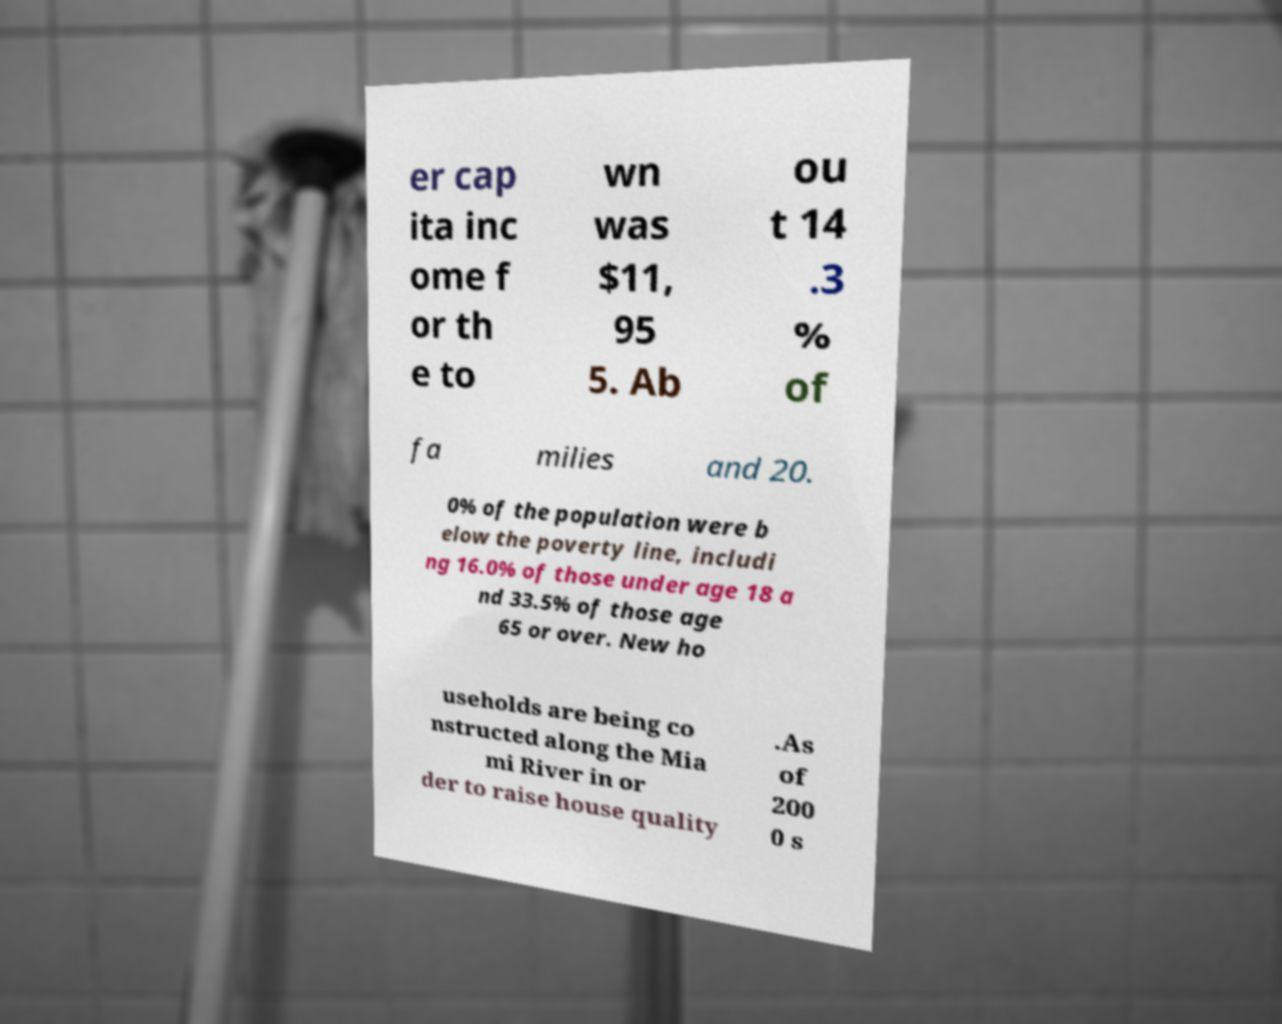Could you extract and type out the text from this image? er cap ita inc ome f or th e to wn was $11, 95 5. Ab ou t 14 .3 % of fa milies and 20. 0% of the population were b elow the poverty line, includi ng 16.0% of those under age 18 a nd 33.5% of those age 65 or over. New ho useholds are being co nstructed along the Mia mi River in or der to raise house quality .As of 200 0 s 